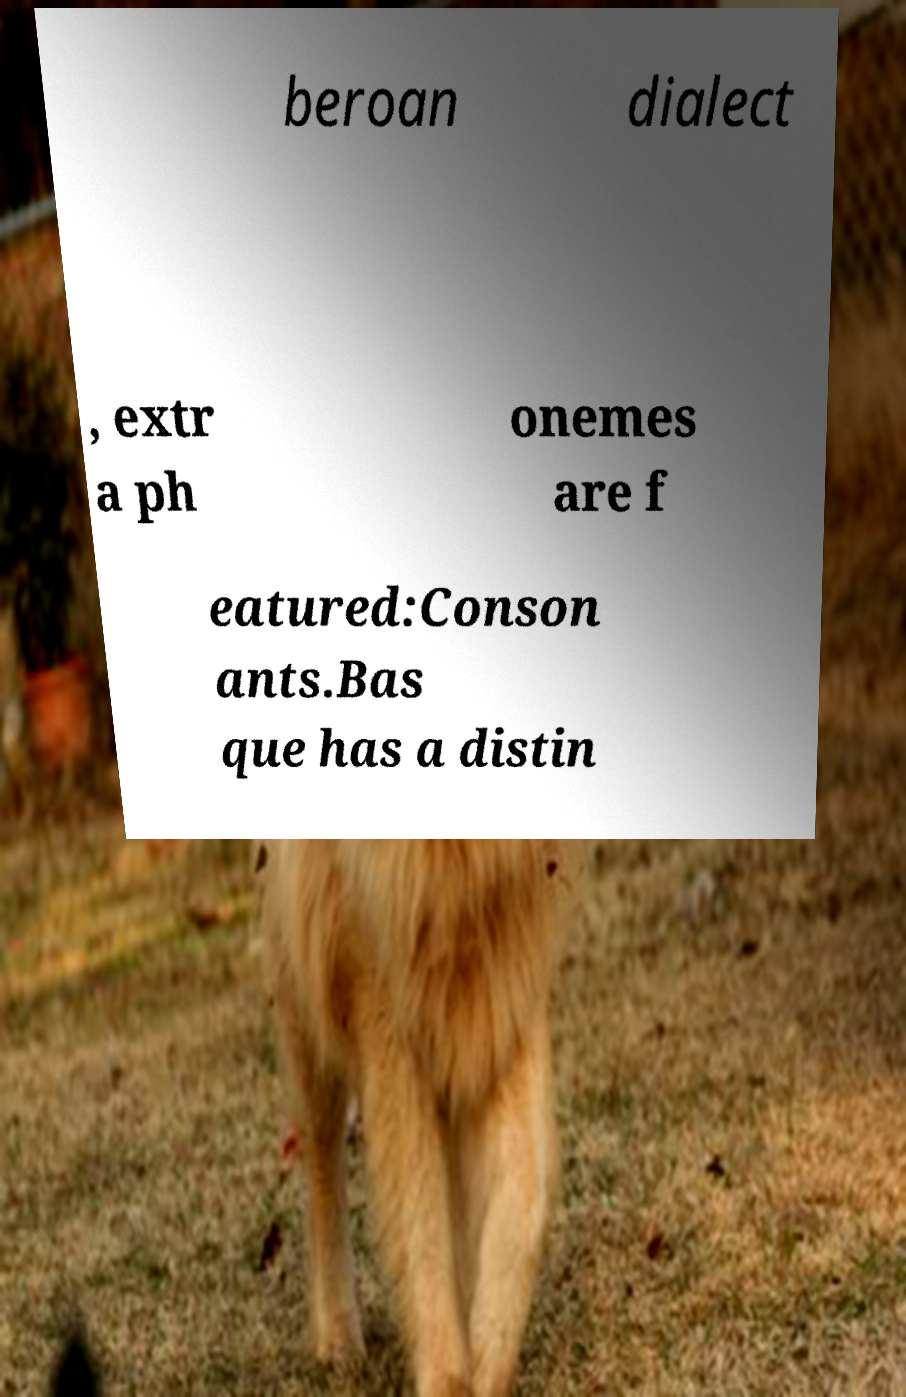I need the written content from this picture converted into text. Can you do that? beroan dialect , extr a ph onemes are f eatured:Conson ants.Bas que has a distin 